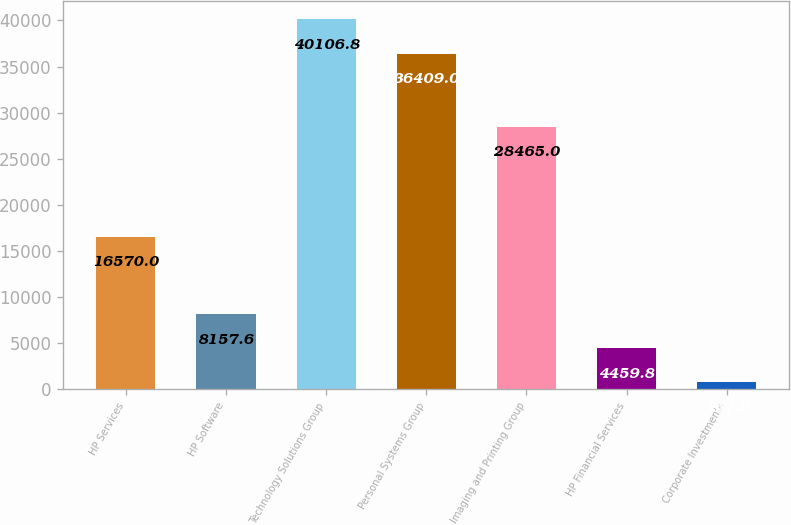Convert chart to OTSL. <chart><loc_0><loc_0><loc_500><loc_500><bar_chart><fcel>HP Services<fcel>HP Software<fcel>Technology Solutions Group<fcel>Personal Systems Group<fcel>Imaging and Printing Group<fcel>HP Financial Services<fcel>Corporate Investments<nl><fcel>16570<fcel>8157.6<fcel>40106.8<fcel>36409<fcel>28465<fcel>4459.8<fcel>762<nl></chart> 